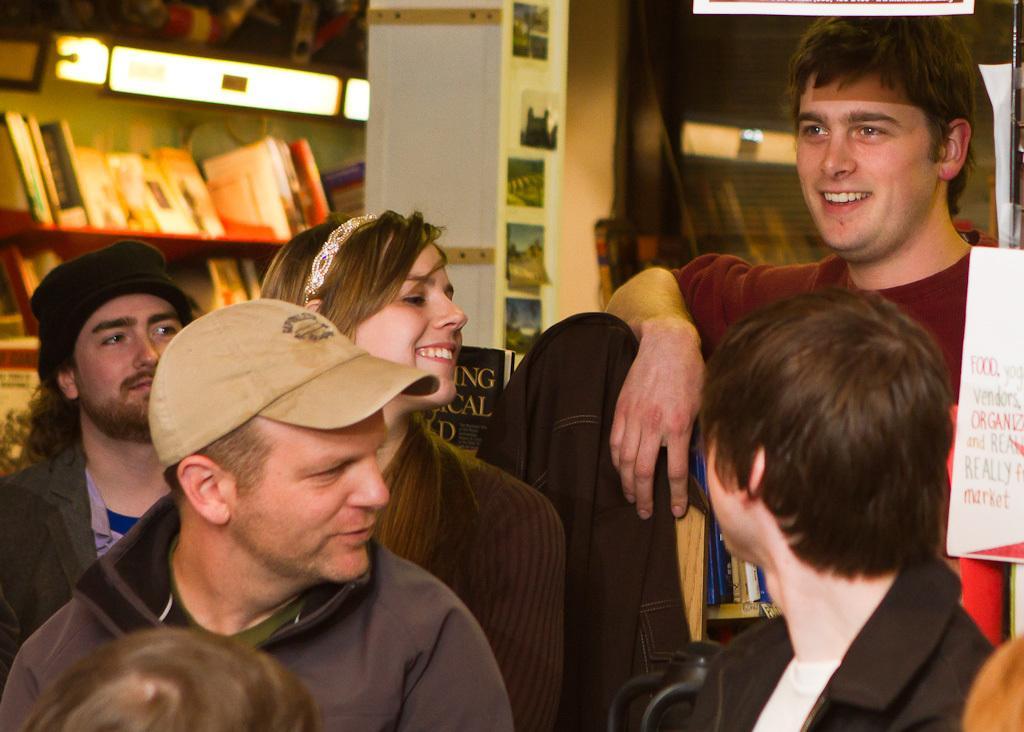Please provide a concise description of this image. In this image there are people. Left side there is a person wearing a cap. Behind him there is a woman. Right side there is a board visible. There is some text on the board. Left side there are shelves having books. There are lights attached to the wall. Middle of the image there is a pillar having few photos attached to it. Background there is a wall. 